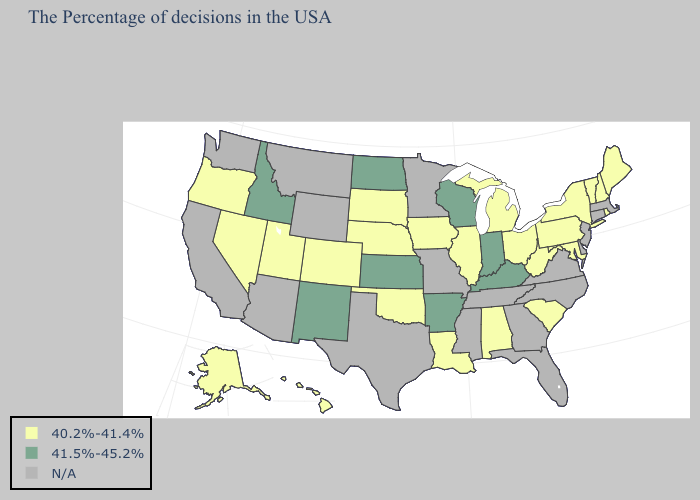What is the lowest value in the USA?
Concise answer only. 40.2%-41.4%. What is the highest value in the West ?
Give a very brief answer. 41.5%-45.2%. Among the states that border Oklahoma , does Colorado have the highest value?
Keep it brief. No. Name the states that have a value in the range 40.2%-41.4%?
Be succinct. Maine, Rhode Island, New Hampshire, Vermont, New York, Maryland, Pennsylvania, South Carolina, West Virginia, Ohio, Michigan, Alabama, Illinois, Louisiana, Iowa, Nebraska, Oklahoma, South Dakota, Colorado, Utah, Nevada, Oregon, Alaska, Hawaii. Among the states that border Ohio , does Pennsylvania have the highest value?
Answer briefly. No. What is the value of Michigan?
Short answer required. 40.2%-41.4%. What is the highest value in the USA?
Concise answer only. 41.5%-45.2%. Name the states that have a value in the range N/A?
Concise answer only. Massachusetts, Connecticut, New Jersey, Delaware, Virginia, North Carolina, Florida, Georgia, Tennessee, Mississippi, Missouri, Minnesota, Texas, Wyoming, Montana, Arizona, California, Washington. Is the legend a continuous bar?
Keep it brief. No. Name the states that have a value in the range 40.2%-41.4%?
Quick response, please. Maine, Rhode Island, New Hampshire, Vermont, New York, Maryland, Pennsylvania, South Carolina, West Virginia, Ohio, Michigan, Alabama, Illinois, Louisiana, Iowa, Nebraska, Oklahoma, South Dakota, Colorado, Utah, Nevada, Oregon, Alaska, Hawaii. Name the states that have a value in the range N/A?
Keep it brief. Massachusetts, Connecticut, New Jersey, Delaware, Virginia, North Carolina, Florida, Georgia, Tennessee, Mississippi, Missouri, Minnesota, Texas, Wyoming, Montana, Arizona, California, Washington. Name the states that have a value in the range 40.2%-41.4%?
Give a very brief answer. Maine, Rhode Island, New Hampshire, Vermont, New York, Maryland, Pennsylvania, South Carolina, West Virginia, Ohio, Michigan, Alabama, Illinois, Louisiana, Iowa, Nebraska, Oklahoma, South Dakota, Colorado, Utah, Nevada, Oregon, Alaska, Hawaii. Which states have the lowest value in the West?
Write a very short answer. Colorado, Utah, Nevada, Oregon, Alaska, Hawaii. What is the lowest value in states that border Michigan?
Short answer required. 40.2%-41.4%. 